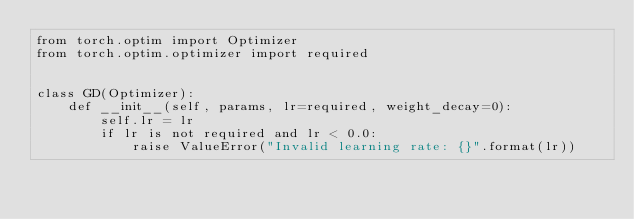Convert code to text. <code><loc_0><loc_0><loc_500><loc_500><_Python_>from torch.optim import Optimizer
from torch.optim.optimizer import required


class GD(Optimizer):
    def __init__(self, params, lr=required, weight_decay=0):
        self.lr = lr
        if lr is not required and lr < 0.0:
            raise ValueError("Invalid learning rate: {}".format(lr))</code> 